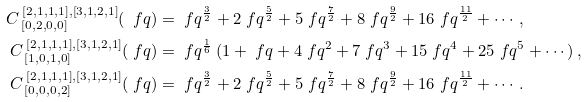Convert formula to latex. <formula><loc_0><loc_0><loc_500><loc_500>C _ { \, [ 0 , 2 , 0 , 0 ] } ^ { \, [ 2 , 1 , 1 , 1 ] , [ 3 , 1 , 2 , 1 ] } ( \ f q ) & = \ f q ^ { \frac { 3 } { 2 } } + 2 \ f q ^ { \frac { 5 } { 2 } } + 5 \ f q ^ { \frac { 7 } { 2 } } + 8 \ f q ^ { \frac { 9 } { 2 } } + 1 6 \ f q ^ { \frac { 1 1 } { 2 } } + \cdots \, , \\ C _ { \, [ 1 , 0 , 1 , 0 ] } ^ { \, [ 2 , 1 , 1 , 1 ] , [ 3 , 1 , 2 , 1 ] } ( \ f q ) & = \ f q ^ { \frac { 1 } { 6 } } \, ( 1 + \ f q + 4 \ f q ^ { 2 } + 7 \ f q ^ { 3 } + 1 5 \ f q ^ { 4 } + 2 5 \ f q ^ { 5 } + \cdots ) \, , \\ C _ { \, [ 0 , 0 , 0 , 2 ] } ^ { \, [ 2 , 1 , 1 , 1 ] , [ 3 , 1 , 2 , 1 ] } ( \ f q ) & = \ f q ^ { \frac { 3 } { 2 } } + 2 \ f q ^ { \frac { 5 } { 2 } } + 5 \ f q ^ { \frac { 7 } { 2 } } + 8 \ f q ^ { \frac { 9 } { 2 } } + 1 6 \ f q ^ { \frac { 1 1 } { 2 } } + \cdots \, .</formula> 